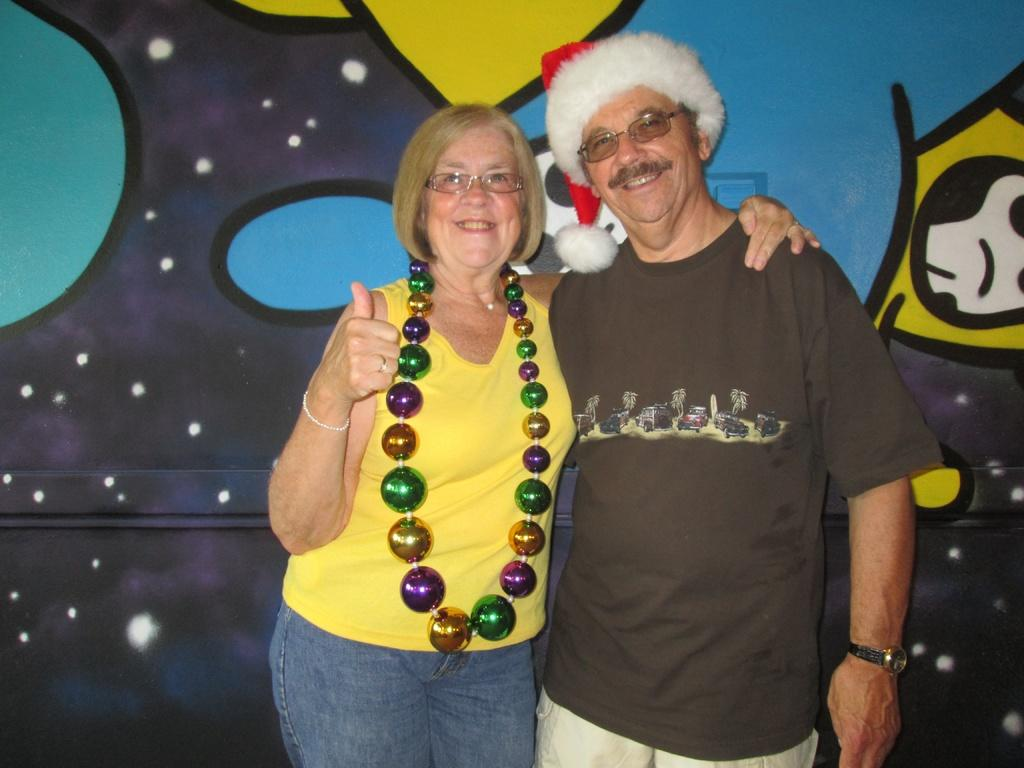Who is the main subject in the image? There is a woman in the image. What is the woman holding in the image? The woman is holding garland balls. Can you describe another person in the image? There is a person with a cap in the image. What can be seen in the background of the image? There is a wall in the background of the image. How does the woman express her emotions through crying in the image? The woman is not crying in the image; she is holding garland balls. What type of stretch is the woman performing in the image? The woman is not performing any stretch in the image; she is holding garland balls. 